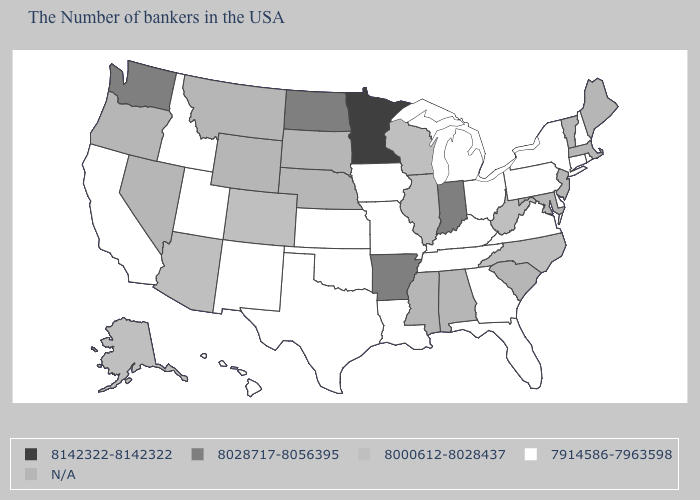What is the value of Ohio?
Be succinct. 7914586-7963598. Does Pennsylvania have the highest value in the USA?
Be succinct. No. What is the value of Maryland?
Short answer required. N/A. Which states have the lowest value in the West?
Quick response, please. New Mexico, Utah, Idaho, California, Hawaii. What is the highest value in the USA?
Keep it brief. 8142322-8142322. Does the map have missing data?
Answer briefly. Yes. Name the states that have a value in the range 8028717-8056395?
Short answer required. Indiana, Arkansas, North Dakota, Washington. What is the value of Georgia?
Answer briefly. 7914586-7963598. What is the value of Vermont?
Concise answer only. N/A. Does Idaho have the lowest value in the West?
Write a very short answer. Yes. What is the value of Montana?
Short answer required. N/A. What is the value of Alabama?
Be succinct. N/A. Among the states that border Colorado , which have the lowest value?
Give a very brief answer. Kansas, Oklahoma, New Mexico, Utah. 